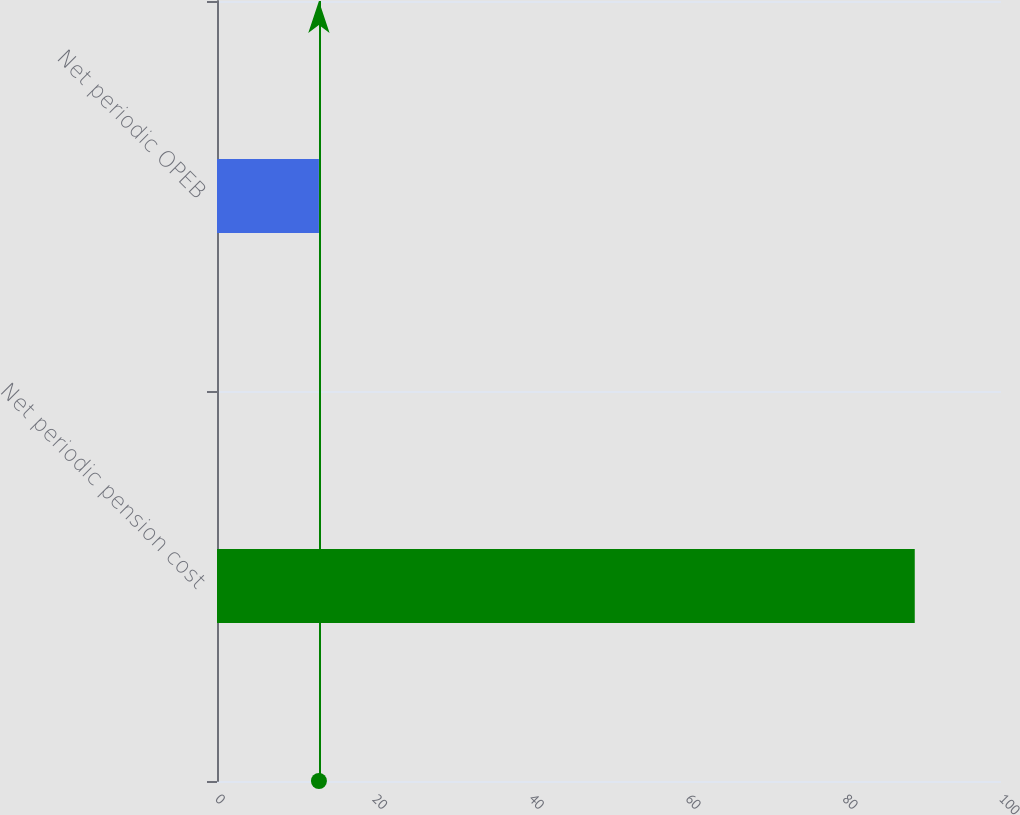Convert chart. <chart><loc_0><loc_0><loc_500><loc_500><bar_chart><fcel>Net periodic pension cost<fcel>Net periodic OPEB<nl><fcel>89<fcel>13<nl></chart> 